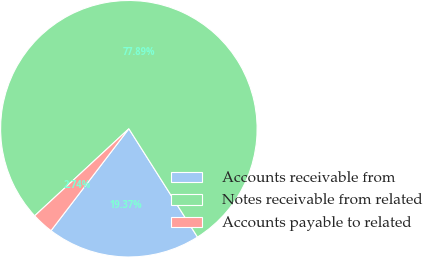<chart> <loc_0><loc_0><loc_500><loc_500><pie_chart><fcel>Accounts receivable from<fcel>Notes receivable from related<fcel>Accounts payable to related<nl><fcel>19.37%<fcel>77.89%<fcel>2.74%<nl></chart> 